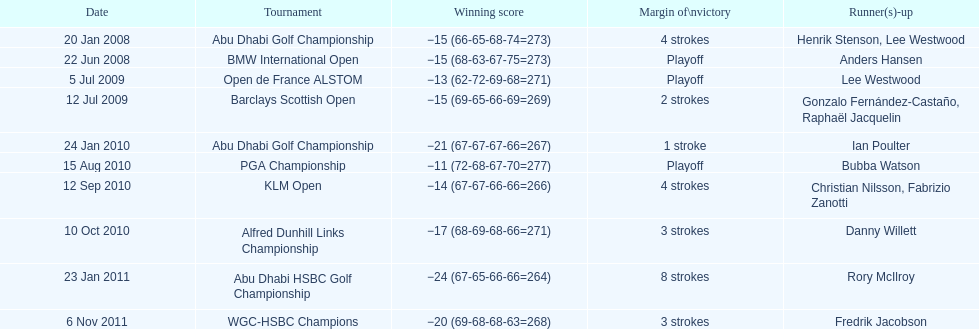Who had the top score in the pga championship? Bubba Watson. 